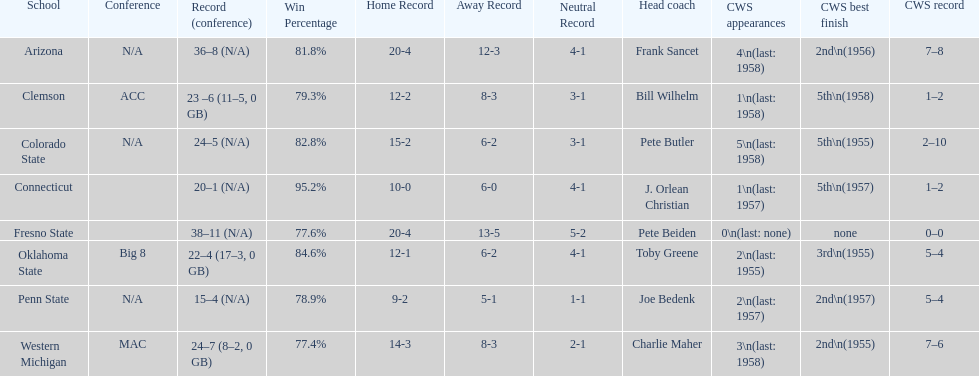How many teams had their cws best finish in 1955? 3. 